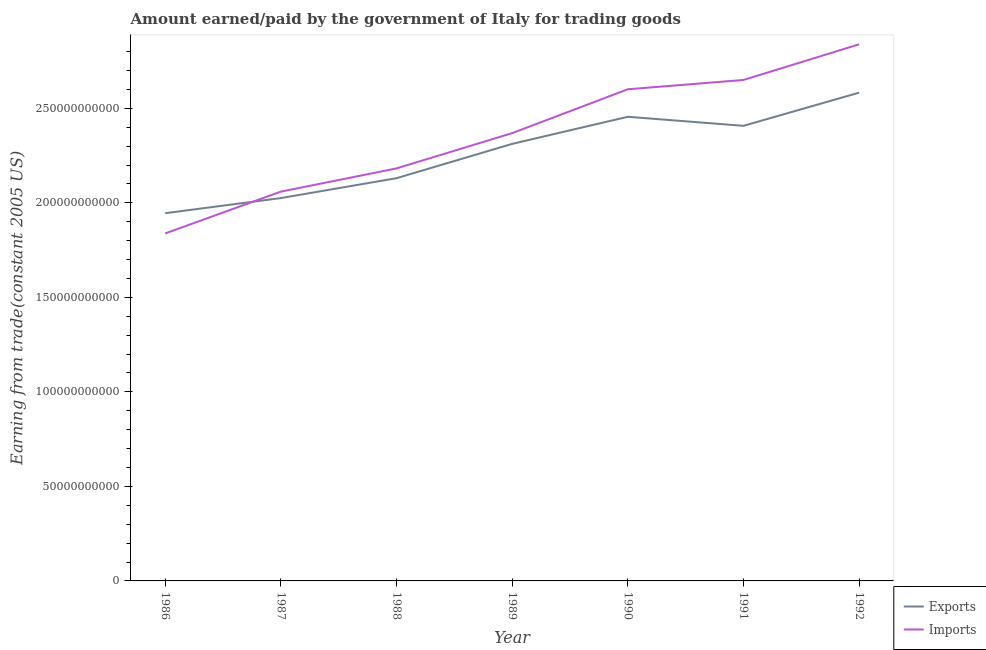How many different coloured lines are there?
Ensure brevity in your answer.  2. Does the line corresponding to amount earned from exports intersect with the line corresponding to amount paid for imports?
Your response must be concise. Yes. What is the amount earned from exports in 1991?
Provide a succinct answer. 2.41e+11. Across all years, what is the maximum amount paid for imports?
Offer a very short reply. 2.84e+11. Across all years, what is the minimum amount earned from exports?
Provide a short and direct response. 1.95e+11. In which year was the amount earned from exports minimum?
Your answer should be very brief. 1986. What is the total amount paid for imports in the graph?
Ensure brevity in your answer.  1.65e+12. What is the difference between the amount earned from exports in 1987 and that in 1989?
Ensure brevity in your answer.  -2.87e+1. What is the difference between the amount earned from exports in 1992 and the amount paid for imports in 1987?
Your response must be concise. 5.23e+1. What is the average amount earned from exports per year?
Your answer should be compact. 2.27e+11. In the year 1986, what is the difference between the amount paid for imports and amount earned from exports?
Give a very brief answer. -1.07e+1. In how many years, is the amount paid for imports greater than 100000000000 US$?
Provide a short and direct response. 7. What is the ratio of the amount earned from exports in 1986 to that in 1990?
Provide a short and direct response. 0.79. Is the amount earned from exports in 1987 less than that in 1989?
Your answer should be compact. Yes. What is the difference between the highest and the second highest amount earned from exports?
Provide a short and direct response. 1.28e+1. What is the difference between the highest and the lowest amount paid for imports?
Give a very brief answer. 1.00e+11. In how many years, is the amount earned from exports greater than the average amount earned from exports taken over all years?
Keep it short and to the point. 4. Does the amount earned from exports monotonically increase over the years?
Offer a very short reply. No. How many lines are there?
Offer a very short reply. 2. How many years are there in the graph?
Give a very brief answer. 7. What is the difference between two consecutive major ticks on the Y-axis?
Ensure brevity in your answer.  5.00e+1. Does the graph contain any zero values?
Your answer should be compact. No. How many legend labels are there?
Keep it short and to the point. 2. What is the title of the graph?
Give a very brief answer. Amount earned/paid by the government of Italy for trading goods. Does "Health Care" appear as one of the legend labels in the graph?
Offer a very short reply. No. What is the label or title of the X-axis?
Make the answer very short. Year. What is the label or title of the Y-axis?
Your answer should be compact. Earning from trade(constant 2005 US). What is the Earning from trade(constant 2005 US) in Exports in 1986?
Offer a terse response. 1.95e+11. What is the Earning from trade(constant 2005 US) in Imports in 1986?
Make the answer very short. 1.84e+11. What is the Earning from trade(constant 2005 US) of Exports in 1987?
Make the answer very short. 2.03e+11. What is the Earning from trade(constant 2005 US) of Imports in 1987?
Your answer should be compact. 2.06e+11. What is the Earning from trade(constant 2005 US) of Exports in 1988?
Give a very brief answer. 2.13e+11. What is the Earning from trade(constant 2005 US) of Imports in 1988?
Provide a short and direct response. 2.18e+11. What is the Earning from trade(constant 2005 US) in Exports in 1989?
Your answer should be compact. 2.31e+11. What is the Earning from trade(constant 2005 US) in Imports in 1989?
Your response must be concise. 2.37e+11. What is the Earning from trade(constant 2005 US) of Exports in 1990?
Provide a short and direct response. 2.46e+11. What is the Earning from trade(constant 2005 US) of Imports in 1990?
Your answer should be very brief. 2.60e+11. What is the Earning from trade(constant 2005 US) of Exports in 1991?
Your response must be concise. 2.41e+11. What is the Earning from trade(constant 2005 US) of Imports in 1991?
Offer a terse response. 2.65e+11. What is the Earning from trade(constant 2005 US) of Exports in 1992?
Provide a succinct answer. 2.58e+11. What is the Earning from trade(constant 2005 US) of Imports in 1992?
Give a very brief answer. 2.84e+11. Across all years, what is the maximum Earning from trade(constant 2005 US) in Exports?
Offer a very short reply. 2.58e+11. Across all years, what is the maximum Earning from trade(constant 2005 US) of Imports?
Your response must be concise. 2.84e+11. Across all years, what is the minimum Earning from trade(constant 2005 US) of Exports?
Offer a very short reply. 1.95e+11. Across all years, what is the minimum Earning from trade(constant 2005 US) in Imports?
Offer a very short reply. 1.84e+11. What is the total Earning from trade(constant 2005 US) in Exports in the graph?
Your response must be concise. 1.59e+12. What is the total Earning from trade(constant 2005 US) in Imports in the graph?
Keep it short and to the point. 1.65e+12. What is the difference between the Earning from trade(constant 2005 US) of Exports in 1986 and that in 1987?
Give a very brief answer. -8.00e+09. What is the difference between the Earning from trade(constant 2005 US) of Imports in 1986 and that in 1987?
Offer a very short reply. -2.21e+1. What is the difference between the Earning from trade(constant 2005 US) in Exports in 1986 and that in 1988?
Keep it short and to the point. -1.85e+1. What is the difference between the Earning from trade(constant 2005 US) in Imports in 1986 and that in 1988?
Ensure brevity in your answer.  -3.44e+1. What is the difference between the Earning from trade(constant 2005 US) in Exports in 1986 and that in 1989?
Your answer should be compact. -3.67e+1. What is the difference between the Earning from trade(constant 2005 US) in Imports in 1986 and that in 1989?
Offer a very short reply. -5.31e+1. What is the difference between the Earning from trade(constant 2005 US) of Exports in 1986 and that in 1990?
Your answer should be compact. -5.10e+1. What is the difference between the Earning from trade(constant 2005 US) of Imports in 1986 and that in 1990?
Make the answer very short. -7.63e+1. What is the difference between the Earning from trade(constant 2005 US) of Exports in 1986 and that in 1991?
Your response must be concise. -4.62e+1. What is the difference between the Earning from trade(constant 2005 US) of Imports in 1986 and that in 1991?
Keep it short and to the point. -8.12e+1. What is the difference between the Earning from trade(constant 2005 US) of Exports in 1986 and that in 1992?
Provide a succinct answer. -6.38e+1. What is the difference between the Earning from trade(constant 2005 US) of Imports in 1986 and that in 1992?
Give a very brief answer. -1.00e+11. What is the difference between the Earning from trade(constant 2005 US) in Exports in 1987 and that in 1988?
Your response must be concise. -1.05e+1. What is the difference between the Earning from trade(constant 2005 US) of Imports in 1987 and that in 1988?
Provide a succinct answer. -1.23e+1. What is the difference between the Earning from trade(constant 2005 US) of Exports in 1987 and that in 1989?
Your answer should be very brief. -2.87e+1. What is the difference between the Earning from trade(constant 2005 US) of Imports in 1987 and that in 1989?
Your response must be concise. -3.09e+1. What is the difference between the Earning from trade(constant 2005 US) in Exports in 1987 and that in 1990?
Provide a succinct answer. -4.30e+1. What is the difference between the Earning from trade(constant 2005 US) of Imports in 1987 and that in 1990?
Ensure brevity in your answer.  -5.41e+1. What is the difference between the Earning from trade(constant 2005 US) of Exports in 1987 and that in 1991?
Provide a succinct answer. -3.82e+1. What is the difference between the Earning from trade(constant 2005 US) in Imports in 1987 and that in 1991?
Ensure brevity in your answer.  -5.91e+1. What is the difference between the Earning from trade(constant 2005 US) of Exports in 1987 and that in 1992?
Keep it short and to the point. -5.58e+1. What is the difference between the Earning from trade(constant 2005 US) of Imports in 1987 and that in 1992?
Your answer should be very brief. -7.79e+1. What is the difference between the Earning from trade(constant 2005 US) of Exports in 1988 and that in 1989?
Provide a succinct answer. -1.82e+1. What is the difference between the Earning from trade(constant 2005 US) of Imports in 1988 and that in 1989?
Your response must be concise. -1.87e+1. What is the difference between the Earning from trade(constant 2005 US) in Exports in 1988 and that in 1990?
Provide a short and direct response. -3.25e+1. What is the difference between the Earning from trade(constant 2005 US) in Imports in 1988 and that in 1990?
Your response must be concise. -4.19e+1. What is the difference between the Earning from trade(constant 2005 US) in Exports in 1988 and that in 1991?
Provide a succinct answer. -2.77e+1. What is the difference between the Earning from trade(constant 2005 US) in Imports in 1988 and that in 1991?
Your response must be concise. -4.68e+1. What is the difference between the Earning from trade(constant 2005 US) in Exports in 1988 and that in 1992?
Keep it short and to the point. -4.53e+1. What is the difference between the Earning from trade(constant 2005 US) of Imports in 1988 and that in 1992?
Keep it short and to the point. -6.56e+1. What is the difference between the Earning from trade(constant 2005 US) in Exports in 1989 and that in 1990?
Give a very brief answer. -1.43e+1. What is the difference between the Earning from trade(constant 2005 US) in Imports in 1989 and that in 1990?
Offer a terse response. -2.32e+1. What is the difference between the Earning from trade(constant 2005 US) in Exports in 1989 and that in 1991?
Provide a succinct answer. -9.54e+09. What is the difference between the Earning from trade(constant 2005 US) in Imports in 1989 and that in 1991?
Your answer should be very brief. -2.81e+1. What is the difference between the Earning from trade(constant 2005 US) in Exports in 1989 and that in 1992?
Keep it short and to the point. -2.71e+1. What is the difference between the Earning from trade(constant 2005 US) of Imports in 1989 and that in 1992?
Provide a short and direct response. -4.70e+1. What is the difference between the Earning from trade(constant 2005 US) in Exports in 1990 and that in 1991?
Provide a succinct answer. 4.78e+09. What is the difference between the Earning from trade(constant 2005 US) of Imports in 1990 and that in 1991?
Your response must be concise. -4.92e+09. What is the difference between the Earning from trade(constant 2005 US) in Exports in 1990 and that in 1992?
Provide a short and direct response. -1.28e+1. What is the difference between the Earning from trade(constant 2005 US) in Imports in 1990 and that in 1992?
Ensure brevity in your answer.  -2.38e+1. What is the difference between the Earning from trade(constant 2005 US) of Exports in 1991 and that in 1992?
Your answer should be very brief. -1.75e+1. What is the difference between the Earning from trade(constant 2005 US) in Imports in 1991 and that in 1992?
Your answer should be compact. -1.89e+1. What is the difference between the Earning from trade(constant 2005 US) of Exports in 1986 and the Earning from trade(constant 2005 US) of Imports in 1987?
Offer a terse response. -1.14e+1. What is the difference between the Earning from trade(constant 2005 US) in Exports in 1986 and the Earning from trade(constant 2005 US) in Imports in 1988?
Offer a very short reply. -2.37e+1. What is the difference between the Earning from trade(constant 2005 US) in Exports in 1986 and the Earning from trade(constant 2005 US) in Imports in 1989?
Offer a terse response. -4.24e+1. What is the difference between the Earning from trade(constant 2005 US) in Exports in 1986 and the Earning from trade(constant 2005 US) in Imports in 1990?
Your answer should be very brief. -6.56e+1. What is the difference between the Earning from trade(constant 2005 US) in Exports in 1986 and the Earning from trade(constant 2005 US) in Imports in 1991?
Offer a very short reply. -7.05e+1. What is the difference between the Earning from trade(constant 2005 US) in Exports in 1986 and the Earning from trade(constant 2005 US) in Imports in 1992?
Give a very brief answer. -8.93e+1. What is the difference between the Earning from trade(constant 2005 US) of Exports in 1987 and the Earning from trade(constant 2005 US) of Imports in 1988?
Provide a succinct answer. -1.57e+1. What is the difference between the Earning from trade(constant 2005 US) in Exports in 1987 and the Earning from trade(constant 2005 US) in Imports in 1989?
Provide a succinct answer. -3.43e+1. What is the difference between the Earning from trade(constant 2005 US) in Exports in 1987 and the Earning from trade(constant 2005 US) in Imports in 1990?
Your answer should be compact. -5.76e+1. What is the difference between the Earning from trade(constant 2005 US) of Exports in 1987 and the Earning from trade(constant 2005 US) of Imports in 1991?
Ensure brevity in your answer.  -6.25e+1. What is the difference between the Earning from trade(constant 2005 US) of Exports in 1987 and the Earning from trade(constant 2005 US) of Imports in 1992?
Provide a succinct answer. -8.13e+1. What is the difference between the Earning from trade(constant 2005 US) of Exports in 1988 and the Earning from trade(constant 2005 US) of Imports in 1989?
Your answer should be very brief. -2.38e+1. What is the difference between the Earning from trade(constant 2005 US) of Exports in 1988 and the Earning from trade(constant 2005 US) of Imports in 1990?
Provide a short and direct response. -4.70e+1. What is the difference between the Earning from trade(constant 2005 US) in Exports in 1988 and the Earning from trade(constant 2005 US) in Imports in 1991?
Your response must be concise. -5.20e+1. What is the difference between the Earning from trade(constant 2005 US) of Exports in 1988 and the Earning from trade(constant 2005 US) of Imports in 1992?
Offer a terse response. -7.08e+1. What is the difference between the Earning from trade(constant 2005 US) of Exports in 1989 and the Earning from trade(constant 2005 US) of Imports in 1990?
Make the answer very short. -2.89e+1. What is the difference between the Earning from trade(constant 2005 US) in Exports in 1989 and the Earning from trade(constant 2005 US) in Imports in 1991?
Provide a short and direct response. -3.38e+1. What is the difference between the Earning from trade(constant 2005 US) of Exports in 1989 and the Earning from trade(constant 2005 US) of Imports in 1992?
Give a very brief answer. -5.27e+1. What is the difference between the Earning from trade(constant 2005 US) in Exports in 1990 and the Earning from trade(constant 2005 US) in Imports in 1991?
Provide a short and direct response. -1.95e+1. What is the difference between the Earning from trade(constant 2005 US) in Exports in 1990 and the Earning from trade(constant 2005 US) in Imports in 1992?
Your response must be concise. -3.83e+1. What is the difference between the Earning from trade(constant 2005 US) of Exports in 1991 and the Earning from trade(constant 2005 US) of Imports in 1992?
Offer a terse response. -4.31e+1. What is the average Earning from trade(constant 2005 US) in Exports per year?
Provide a succinct answer. 2.27e+11. What is the average Earning from trade(constant 2005 US) in Imports per year?
Ensure brevity in your answer.  2.36e+11. In the year 1986, what is the difference between the Earning from trade(constant 2005 US) in Exports and Earning from trade(constant 2005 US) in Imports?
Keep it short and to the point. 1.07e+1. In the year 1987, what is the difference between the Earning from trade(constant 2005 US) in Exports and Earning from trade(constant 2005 US) in Imports?
Your answer should be very brief. -3.41e+09. In the year 1988, what is the difference between the Earning from trade(constant 2005 US) of Exports and Earning from trade(constant 2005 US) of Imports?
Your response must be concise. -5.18e+09. In the year 1989, what is the difference between the Earning from trade(constant 2005 US) in Exports and Earning from trade(constant 2005 US) in Imports?
Offer a very short reply. -5.67e+09. In the year 1990, what is the difference between the Earning from trade(constant 2005 US) of Exports and Earning from trade(constant 2005 US) of Imports?
Your response must be concise. -1.46e+1. In the year 1991, what is the difference between the Earning from trade(constant 2005 US) in Exports and Earning from trade(constant 2005 US) in Imports?
Make the answer very short. -2.43e+1. In the year 1992, what is the difference between the Earning from trade(constant 2005 US) in Exports and Earning from trade(constant 2005 US) in Imports?
Your answer should be very brief. -2.56e+1. What is the ratio of the Earning from trade(constant 2005 US) of Exports in 1986 to that in 1987?
Offer a terse response. 0.96. What is the ratio of the Earning from trade(constant 2005 US) in Imports in 1986 to that in 1987?
Provide a short and direct response. 0.89. What is the ratio of the Earning from trade(constant 2005 US) in Exports in 1986 to that in 1988?
Offer a terse response. 0.91. What is the ratio of the Earning from trade(constant 2005 US) of Imports in 1986 to that in 1988?
Provide a short and direct response. 0.84. What is the ratio of the Earning from trade(constant 2005 US) of Exports in 1986 to that in 1989?
Provide a short and direct response. 0.84. What is the ratio of the Earning from trade(constant 2005 US) in Imports in 1986 to that in 1989?
Make the answer very short. 0.78. What is the ratio of the Earning from trade(constant 2005 US) of Exports in 1986 to that in 1990?
Give a very brief answer. 0.79. What is the ratio of the Earning from trade(constant 2005 US) in Imports in 1986 to that in 1990?
Your answer should be compact. 0.71. What is the ratio of the Earning from trade(constant 2005 US) of Exports in 1986 to that in 1991?
Provide a short and direct response. 0.81. What is the ratio of the Earning from trade(constant 2005 US) of Imports in 1986 to that in 1991?
Keep it short and to the point. 0.69. What is the ratio of the Earning from trade(constant 2005 US) of Exports in 1986 to that in 1992?
Your answer should be very brief. 0.75. What is the ratio of the Earning from trade(constant 2005 US) in Imports in 1986 to that in 1992?
Offer a very short reply. 0.65. What is the ratio of the Earning from trade(constant 2005 US) in Exports in 1987 to that in 1988?
Your response must be concise. 0.95. What is the ratio of the Earning from trade(constant 2005 US) of Imports in 1987 to that in 1988?
Ensure brevity in your answer.  0.94. What is the ratio of the Earning from trade(constant 2005 US) in Exports in 1987 to that in 1989?
Your answer should be very brief. 0.88. What is the ratio of the Earning from trade(constant 2005 US) in Imports in 1987 to that in 1989?
Make the answer very short. 0.87. What is the ratio of the Earning from trade(constant 2005 US) in Exports in 1987 to that in 1990?
Your answer should be very brief. 0.82. What is the ratio of the Earning from trade(constant 2005 US) of Imports in 1987 to that in 1990?
Your response must be concise. 0.79. What is the ratio of the Earning from trade(constant 2005 US) of Exports in 1987 to that in 1991?
Your answer should be very brief. 0.84. What is the ratio of the Earning from trade(constant 2005 US) in Imports in 1987 to that in 1991?
Make the answer very short. 0.78. What is the ratio of the Earning from trade(constant 2005 US) in Exports in 1987 to that in 1992?
Give a very brief answer. 0.78. What is the ratio of the Earning from trade(constant 2005 US) of Imports in 1987 to that in 1992?
Your answer should be very brief. 0.73. What is the ratio of the Earning from trade(constant 2005 US) in Exports in 1988 to that in 1989?
Make the answer very short. 0.92. What is the ratio of the Earning from trade(constant 2005 US) in Imports in 1988 to that in 1989?
Your answer should be very brief. 0.92. What is the ratio of the Earning from trade(constant 2005 US) in Exports in 1988 to that in 1990?
Provide a succinct answer. 0.87. What is the ratio of the Earning from trade(constant 2005 US) in Imports in 1988 to that in 1990?
Your answer should be very brief. 0.84. What is the ratio of the Earning from trade(constant 2005 US) of Exports in 1988 to that in 1991?
Provide a short and direct response. 0.88. What is the ratio of the Earning from trade(constant 2005 US) in Imports in 1988 to that in 1991?
Your answer should be very brief. 0.82. What is the ratio of the Earning from trade(constant 2005 US) in Exports in 1988 to that in 1992?
Keep it short and to the point. 0.82. What is the ratio of the Earning from trade(constant 2005 US) of Imports in 1988 to that in 1992?
Provide a succinct answer. 0.77. What is the ratio of the Earning from trade(constant 2005 US) of Exports in 1989 to that in 1990?
Your response must be concise. 0.94. What is the ratio of the Earning from trade(constant 2005 US) in Imports in 1989 to that in 1990?
Ensure brevity in your answer.  0.91. What is the ratio of the Earning from trade(constant 2005 US) of Exports in 1989 to that in 1991?
Provide a short and direct response. 0.96. What is the ratio of the Earning from trade(constant 2005 US) in Imports in 1989 to that in 1991?
Offer a terse response. 0.89. What is the ratio of the Earning from trade(constant 2005 US) of Exports in 1989 to that in 1992?
Keep it short and to the point. 0.9. What is the ratio of the Earning from trade(constant 2005 US) in Imports in 1989 to that in 1992?
Keep it short and to the point. 0.83. What is the ratio of the Earning from trade(constant 2005 US) of Exports in 1990 to that in 1991?
Offer a terse response. 1.02. What is the ratio of the Earning from trade(constant 2005 US) of Imports in 1990 to that in 1991?
Your answer should be compact. 0.98. What is the ratio of the Earning from trade(constant 2005 US) in Exports in 1990 to that in 1992?
Offer a terse response. 0.95. What is the ratio of the Earning from trade(constant 2005 US) in Imports in 1990 to that in 1992?
Your response must be concise. 0.92. What is the ratio of the Earning from trade(constant 2005 US) in Exports in 1991 to that in 1992?
Your answer should be compact. 0.93. What is the ratio of the Earning from trade(constant 2005 US) of Imports in 1991 to that in 1992?
Give a very brief answer. 0.93. What is the difference between the highest and the second highest Earning from trade(constant 2005 US) of Exports?
Keep it short and to the point. 1.28e+1. What is the difference between the highest and the second highest Earning from trade(constant 2005 US) in Imports?
Your answer should be very brief. 1.89e+1. What is the difference between the highest and the lowest Earning from trade(constant 2005 US) of Exports?
Keep it short and to the point. 6.38e+1. What is the difference between the highest and the lowest Earning from trade(constant 2005 US) in Imports?
Keep it short and to the point. 1.00e+11. 